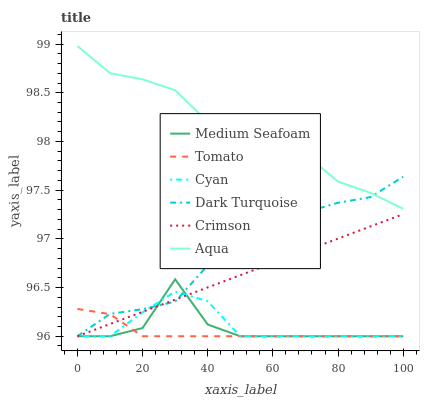Does Tomato have the minimum area under the curve?
Answer yes or no. Yes. Does Aqua have the maximum area under the curve?
Answer yes or no. Yes. Does Dark Turquoise have the minimum area under the curve?
Answer yes or no. No. Does Dark Turquoise have the maximum area under the curve?
Answer yes or no. No. Is Crimson the smoothest?
Answer yes or no. Yes. Is Medium Seafoam the roughest?
Answer yes or no. Yes. Is Dark Turquoise the smoothest?
Answer yes or no. No. Is Dark Turquoise the roughest?
Answer yes or no. No. Does Tomato have the lowest value?
Answer yes or no. Yes. Does Aqua have the lowest value?
Answer yes or no. No. Does Aqua have the highest value?
Answer yes or no. Yes. Does Dark Turquoise have the highest value?
Answer yes or no. No. Is Crimson less than Aqua?
Answer yes or no. Yes. Is Aqua greater than Cyan?
Answer yes or no. Yes. Does Aqua intersect Dark Turquoise?
Answer yes or no. Yes. Is Aqua less than Dark Turquoise?
Answer yes or no. No. Is Aqua greater than Dark Turquoise?
Answer yes or no. No. Does Crimson intersect Aqua?
Answer yes or no. No. 